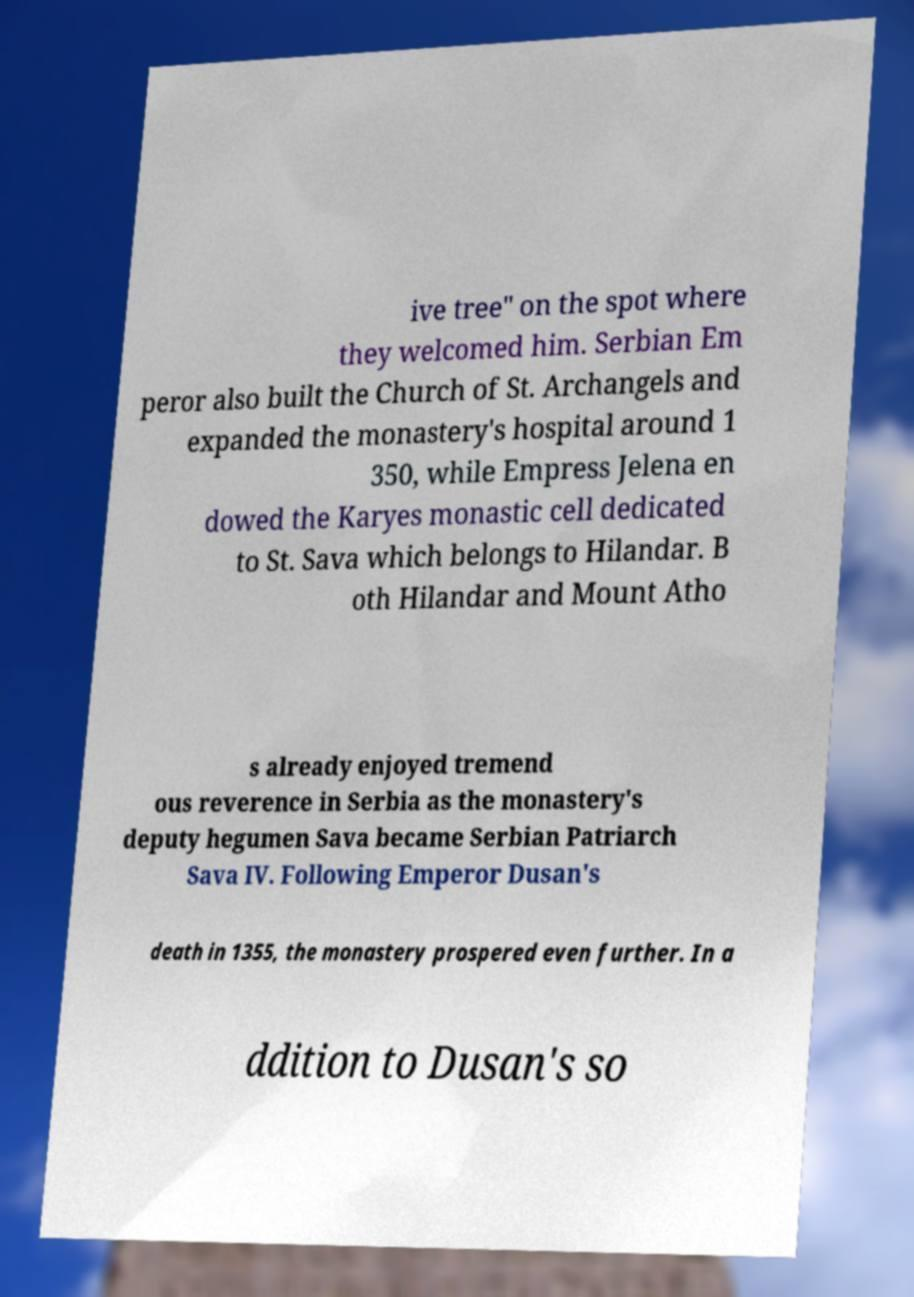Could you assist in decoding the text presented in this image and type it out clearly? ive tree" on the spot where they welcomed him. Serbian Em peror also built the Church of St. Archangels and expanded the monastery's hospital around 1 350, while Empress Jelena en dowed the Karyes monastic cell dedicated to St. Sava which belongs to Hilandar. B oth Hilandar and Mount Atho s already enjoyed tremend ous reverence in Serbia as the monastery's deputy hegumen Sava became Serbian Patriarch Sava IV. Following Emperor Dusan's death in 1355, the monastery prospered even further. In a ddition to Dusan's so 